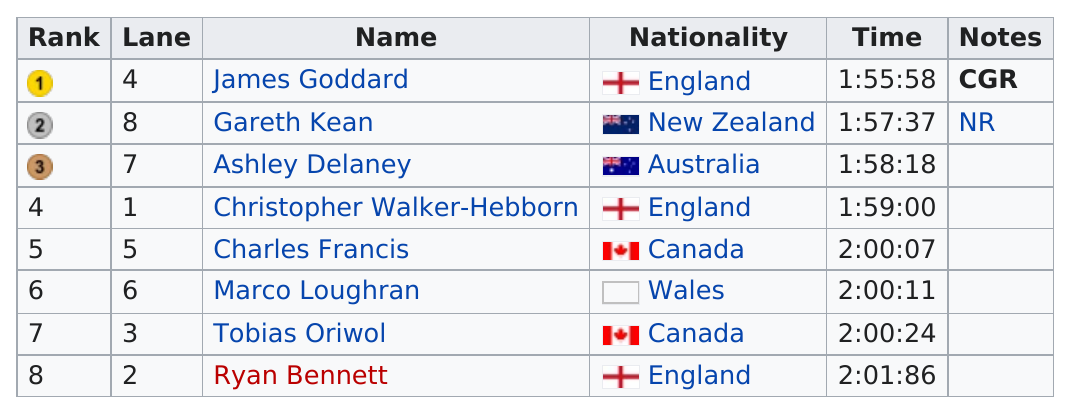Give some essential details in this illustration. The second longest time was 2 hours and 24 minutes. England performed better in the race compared to Canada. Ashley Delaney is the only swimmer from Australia who has competed. Canada had 2 total competitors in the competition. The total number of names is 8. 